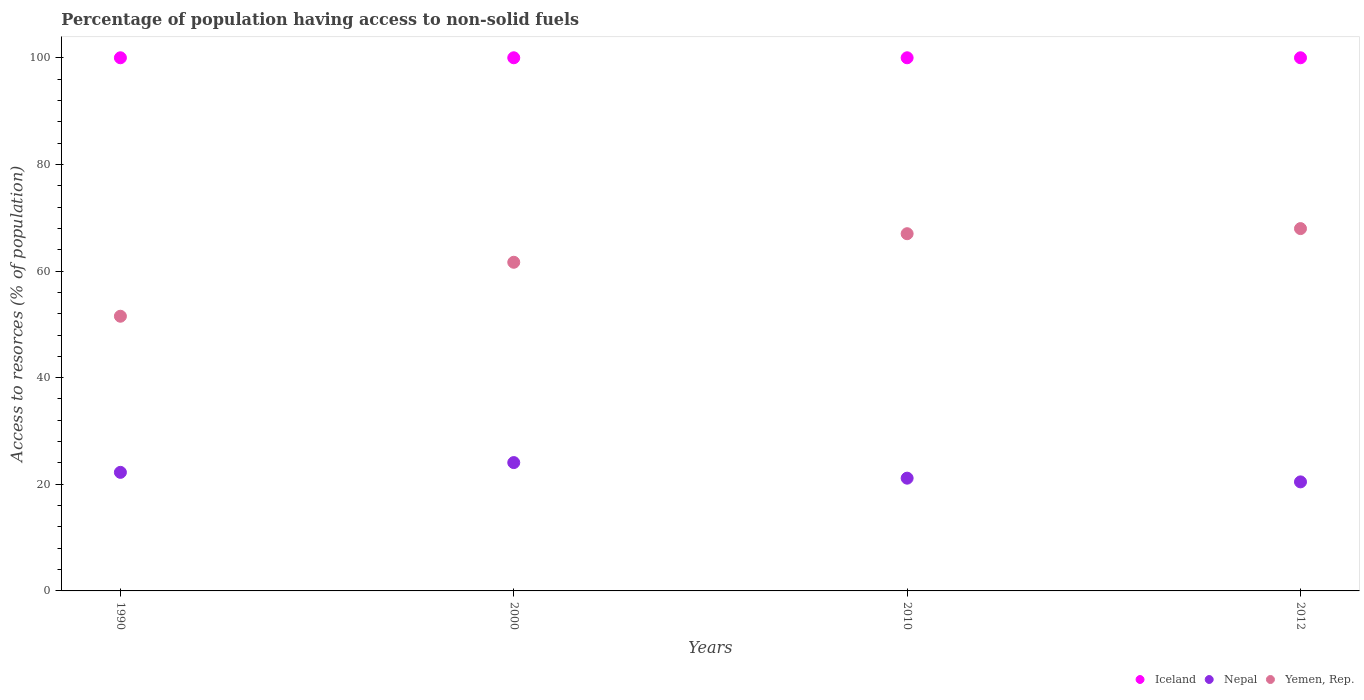Is the number of dotlines equal to the number of legend labels?
Offer a terse response. Yes. What is the percentage of population having access to non-solid fuels in Nepal in 2012?
Your answer should be compact. 20.45. Across all years, what is the maximum percentage of population having access to non-solid fuels in Nepal?
Offer a terse response. 24.07. Across all years, what is the minimum percentage of population having access to non-solid fuels in Yemen, Rep.?
Your answer should be compact. 51.52. What is the total percentage of population having access to non-solid fuels in Iceland in the graph?
Offer a very short reply. 400. What is the difference between the percentage of population having access to non-solid fuels in Nepal in 2000 and that in 2012?
Your answer should be very brief. 3.62. What is the difference between the percentage of population having access to non-solid fuels in Iceland in 1990 and the percentage of population having access to non-solid fuels in Yemen, Rep. in 2012?
Make the answer very short. 32.04. What is the average percentage of population having access to non-solid fuels in Nepal per year?
Ensure brevity in your answer.  21.98. In the year 1990, what is the difference between the percentage of population having access to non-solid fuels in Yemen, Rep. and percentage of population having access to non-solid fuels in Nepal?
Provide a short and direct response. 29.28. In how many years, is the percentage of population having access to non-solid fuels in Nepal greater than 20 %?
Make the answer very short. 4. What is the ratio of the percentage of population having access to non-solid fuels in Iceland in 2000 to that in 2012?
Provide a succinct answer. 1. Is the percentage of population having access to non-solid fuels in Yemen, Rep. in 1990 less than that in 2000?
Offer a terse response. Yes. Is the difference between the percentage of population having access to non-solid fuels in Yemen, Rep. in 2000 and 2012 greater than the difference between the percentage of population having access to non-solid fuels in Nepal in 2000 and 2012?
Offer a terse response. No. What is the difference between the highest and the second highest percentage of population having access to non-solid fuels in Nepal?
Ensure brevity in your answer.  1.83. What is the difference between the highest and the lowest percentage of population having access to non-solid fuels in Nepal?
Your response must be concise. 3.62. In how many years, is the percentage of population having access to non-solid fuels in Iceland greater than the average percentage of population having access to non-solid fuels in Iceland taken over all years?
Make the answer very short. 0. Is the sum of the percentage of population having access to non-solid fuels in Iceland in 2000 and 2012 greater than the maximum percentage of population having access to non-solid fuels in Nepal across all years?
Provide a short and direct response. Yes. Is the percentage of population having access to non-solid fuels in Yemen, Rep. strictly greater than the percentage of population having access to non-solid fuels in Iceland over the years?
Make the answer very short. No. Is the percentage of population having access to non-solid fuels in Yemen, Rep. strictly less than the percentage of population having access to non-solid fuels in Nepal over the years?
Make the answer very short. No. What is the difference between two consecutive major ticks on the Y-axis?
Your response must be concise. 20. Are the values on the major ticks of Y-axis written in scientific E-notation?
Give a very brief answer. No. Does the graph contain any zero values?
Provide a succinct answer. No. Where does the legend appear in the graph?
Make the answer very short. Bottom right. How many legend labels are there?
Keep it short and to the point. 3. What is the title of the graph?
Your response must be concise. Percentage of population having access to non-solid fuels. What is the label or title of the Y-axis?
Keep it short and to the point. Access to resorces (% of population). What is the Access to resorces (% of population) in Iceland in 1990?
Offer a very short reply. 100. What is the Access to resorces (% of population) in Nepal in 1990?
Provide a short and direct response. 22.24. What is the Access to resorces (% of population) of Yemen, Rep. in 1990?
Offer a very short reply. 51.52. What is the Access to resorces (% of population) in Nepal in 2000?
Your answer should be compact. 24.07. What is the Access to resorces (% of population) of Yemen, Rep. in 2000?
Provide a succinct answer. 61.64. What is the Access to resorces (% of population) in Nepal in 2010?
Your answer should be compact. 21.15. What is the Access to resorces (% of population) in Yemen, Rep. in 2010?
Keep it short and to the point. 67. What is the Access to resorces (% of population) in Nepal in 2012?
Provide a succinct answer. 20.45. What is the Access to resorces (% of population) in Yemen, Rep. in 2012?
Your answer should be compact. 67.96. Across all years, what is the maximum Access to resorces (% of population) in Nepal?
Provide a succinct answer. 24.07. Across all years, what is the maximum Access to resorces (% of population) of Yemen, Rep.?
Offer a very short reply. 67.96. Across all years, what is the minimum Access to resorces (% of population) of Iceland?
Make the answer very short. 100. Across all years, what is the minimum Access to resorces (% of population) of Nepal?
Keep it short and to the point. 20.45. Across all years, what is the minimum Access to resorces (% of population) in Yemen, Rep.?
Offer a terse response. 51.52. What is the total Access to resorces (% of population) in Nepal in the graph?
Give a very brief answer. 87.91. What is the total Access to resorces (% of population) of Yemen, Rep. in the graph?
Ensure brevity in your answer.  248.13. What is the difference between the Access to resorces (% of population) in Nepal in 1990 and that in 2000?
Your answer should be very brief. -1.83. What is the difference between the Access to resorces (% of population) of Yemen, Rep. in 1990 and that in 2000?
Your answer should be very brief. -10.12. What is the difference between the Access to resorces (% of population) in Iceland in 1990 and that in 2010?
Provide a short and direct response. 0. What is the difference between the Access to resorces (% of population) of Nepal in 1990 and that in 2010?
Offer a very short reply. 1.09. What is the difference between the Access to resorces (% of population) in Yemen, Rep. in 1990 and that in 2010?
Your response must be concise. -15.48. What is the difference between the Access to resorces (% of population) in Iceland in 1990 and that in 2012?
Keep it short and to the point. 0. What is the difference between the Access to resorces (% of population) in Nepal in 1990 and that in 2012?
Your answer should be compact. 1.79. What is the difference between the Access to resorces (% of population) in Yemen, Rep. in 1990 and that in 2012?
Make the answer very short. -16.44. What is the difference between the Access to resorces (% of population) of Iceland in 2000 and that in 2010?
Your response must be concise. 0. What is the difference between the Access to resorces (% of population) in Nepal in 2000 and that in 2010?
Offer a terse response. 2.92. What is the difference between the Access to resorces (% of population) of Yemen, Rep. in 2000 and that in 2010?
Offer a terse response. -5.36. What is the difference between the Access to resorces (% of population) of Iceland in 2000 and that in 2012?
Make the answer very short. 0. What is the difference between the Access to resorces (% of population) in Nepal in 2000 and that in 2012?
Keep it short and to the point. 3.62. What is the difference between the Access to resorces (% of population) of Yemen, Rep. in 2000 and that in 2012?
Your answer should be very brief. -6.32. What is the difference between the Access to resorces (% of population) in Nepal in 2010 and that in 2012?
Ensure brevity in your answer.  0.7. What is the difference between the Access to resorces (% of population) in Yemen, Rep. in 2010 and that in 2012?
Make the answer very short. -0.96. What is the difference between the Access to resorces (% of population) in Iceland in 1990 and the Access to resorces (% of population) in Nepal in 2000?
Offer a terse response. 75.93. What is the difference between the Access to resorces (% of population) of Iceland in 1990 and the Access to resorces (% of population) of Yemen, Rep. in 2000?
Offer a very short reply. 38.36. What is the difference between the Access to resorces (% of population) of Nepal in 1990 and the Access to resorces (% of population) of Yemen, Rep. in 2000?
Make the answer very short. -39.4. What is the difference between the Access to resorces (% of population) in Iceland in 1990 and the Access to resorces (% of population) in Nepal in 2010?
Your answer should be compact. 78.85. What is the difference between the Access to resorces (% of population) in Iceland in 1990 and the Access to resorces (% of population) in Yemen, Rep. in 2010?
Offer a very short reply. 33. What is the difference between the Access to resorces (% of population) in Nepal in 1990 and the Access to resorces (% of population) in Yemen, Rep. in 2010?
Your answer should be compact. -44.76. What is the difference between the Access to resorces (% of population) of Iceland in 1990 and the Access to resorces (% of population) of Nepal in 2012?
Ensure brevity in your answer.  79.55. What is the difference between the Access to resorces (% of population) in Iceland in 1990 and the Access to resorces (% of population) in Yemen, Rep. in 2012?
Your answer should be compact. 32.04. What is the difference between the Access to resorces (% of population) in Nepal in 1990 and the Access to resorces (% of population) in Yemen, Rep. in 2012?
Offer a terse response. -45.72. What is the difference between the Access to resorces (% of population) in Iceland in 2000 and the Access to resorces (% of population) in Nepal in 2010?
Ensure brevity in your answer.  78.85. What is the difference between the Access to resorces (% of population) of Iceland in 2000 and the Access to resorces (% of population) of Yemen, Rep. in 2010?
Provide a short and direct response. 33. What is the difference between the Access to resorces (% of population) in Nepal in 2000 and the Access to resorces (% of population) in Yemen, Rep. in 2010?
Offer a very short reply. -42.93. What is the difference between the Access to resorces (% of population) in Iceland in 2000 and the Access to resorces (% of population) in Nepal in 2012?
Ensure brevity in your answer.  79.55. What is the difference between the Access to resorces (% of population) of Iceland in 2000 and the Access to resorces (% of population) of Yemen, Rep. in 2012?
Ensure brevity in your answer.  32.04. What is the difference between the Access to resorces (% of population) of Nepal in 2000 and the Access to resorces (% of population) of Yemen, Rep. in 2012?
Provide a short and direct response. -43.89. What is the difference between the Access to resorces (% of population) of Iceland in 2010 and the Access to resorces (% of population) of Nepal in 2012?
Provide a short and direct response. 79.55. What is the difference between the Access to resorces (% of population) of Iceland in 2010 and the Access to resorces (% of population) of Yemen, Rep. in 2012?
Your answer should be very brief. 32.04. What is the difference between the Access to resorces (% of population) in Nepal in 2010 and the Access to resorces (% of population) in Yemen, Rep. in 2012?
Your answer should be very brief. -46.81. What is the average Access to resorces (% of population) in Iceland per year?
Provide a short and direct response. 100. What is the average Access to resorces (% of population) in Nepal per year?
Your answer should be compact. 21.98. What is the average Access to resorces (% of population) of Yemen, Rep. per year?
Give a very brief answer. 62.03. In the year 1990, what is the difference between the Access to resorces (% of population) of Iceland and Access to resorces (% of population) of Nepal?
Your answer should be very brief. 77.76. In the year 1990, what is the difference between the Access to resorces (% of population) in Iceland and Access to resorces (% of population) in Yemen, Rep.?
Your response must be concise. 48.48. In the year 1990, what is the difference between the Access to resorces (% of population) in Nepal and Access to resorces (% of population) in Yemen, Rep.?
Ensure brevity in your answer.  -29.28. In the year 2000, what is the difference between the Access to resorces (% of population) of Iceland and Access to resorces (% of population) of Nepal?
Ensure brevity in your answer.  75.93. In the year 2000, what is the difference between the Access to resorces (% of population) of Iceland and Access to resorces (% of population) of Yemen, Rep.?
Give a very brief answer. 38.36. In the year 2000, what is the difference between the Access to resorces (% of population) in Nepal and Access to resorces (% of population) in Yemen, Rep.?
Make the answer very short. -37.57. In the year 2010, what is the difference between the Access to resorces (% of population) of Iceland and Access to resorces (% of population) of Nepal?
Your response must be concise. 78.85. In the year 2010, what is the difference between the Access to resorces (% of population) in Iceland and Access to resorces (% of population) in Yemen, Rep.?
Make the answer very short. 33. In the year 2010, what is the difference between the Access to resorces (% of population) of Nepal and Access to resorces (% of population) of Yemen, Rep.?
Provide a succinct answer. -45.85. In the year 2012, what is the difference between the Access to resorces (% of population) of Iceland and Access to resorces (% of population) of Nepal?
Offer a very short reply. 79.55. In the year 2012, what is the difference between the Access to resorces (% of population) of Iceland and Access to resorces (% of population) of Yemen, Rep.?
Give a very brief answer. 32.04. In the year 2012, what is the difference between the Access to resorces (% of population) in Nepal and Access to resorces (% of population) in Yemen, Rep.?
Give a very brief answer. -47.51. What is the ratio of the Access to resorces (% of population) in Nepal in 1990 to that in 2000?
Your response must be concise. 0.92. What is the ratio of the Access to resorces (% of population) in Yemen, Rep. in 1990 to that in 2000?
Provide a succinct answer. 0.84. What is the ratio of the Access to resorces (% of population) of Nepal in 1990 to that in 2010?
Your answer should be very brief. 1.05. What is the ratio of the Access to resorces (% of population) in Yemen, Rep. in 1990 to that in 2010?
Your response must be concise. 0.77. What is the ratio of the Access to resorces (% of population) in Iceland in 1990 to that in 2012?
Your response must be concise. 1. What is the ratio of the Access to resorces (% of population) of Nepal in 1990 to that in 2012?
Make the answer very short. 1.09. What is the ratio of the Access to resorces (% of population) in Yemen, Rep. in 1990 to that in 2012?
Ensure brevity in your answer.  0.76. What is the ratio of the Access to resorces (% of population) in Nepal in 2000 to that in 2010?
Your answer should be very brief. 1.14. What is the ratio of the Access to resorces (% of population) in Yemen, Rep. in 2000 to that in 2010?
Offer a terse response. 0.92. What is the ratio of the Access to resorces (% of population) of Iceland in 2000 to that in 2012?
Your answer should be compact. 1. What is the ratio of the Access to resorces (% of population) in Nepal in 2000 to that in 2012?
Give a very brief answer. 1.18. What is the ratio of the Access to resorces (% of population) in Yemen, Rep. in 2000 to that in 2012?
Provide a short and direct response. 0.91. What is the ratio of the Access to resorces (% of population) in Iceland in 2010 to that in 2012?
Ensure brevity in your answer.  1. What is the ratio of the Access to resorces (% of population) in Nepal in 2010 to that in 2012?
Your answer should be compact. 1.03. What is the ratio of the Access to resorces (% of population) in Yemen, Rep. in 2010 to that in 2012?
Your response must be concise. 0.99. What is the difference between the highest and the second highest Access to resorces (% of population) in Iceland?
Your response must be concise. 0. What is the difference between the highest and the second highest Access to resorces (% of population) in Nepal?
Offer a very short reply. 1.83. What is the difference between the highest and the second highest Access to resorces (% of population) of Yemen, Rep.?
Ensure brevity in your answer.  0.96. What is the difference between the highest and the lowest Access to resorces (% of population) in Iceland?
Offer a very short reply. 0. What is the difference between the highest and the lowest Access to resorces (% of population) of Nepal?
Provide a short and direct response. 3.62. What is the difference between the highest and the lowest Access to resorces (% of population) of Yemen, Rep.?
Provide a succinct answer. 16.44. 